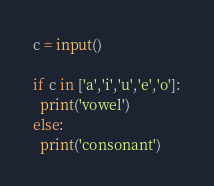Convert code to text. <code><loc_0><loc_0><loc_500><loc_500><_Python_>c = input()

if c in ['a','i','u','e','o']:
  print('vowel')
else:
  print('consonant')</code> 